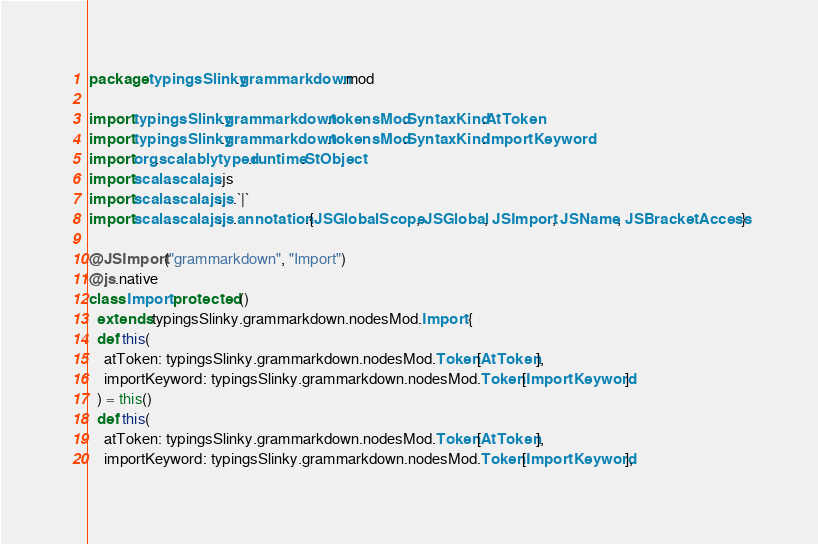<code> <loc_0><loc_0><loc_500><loc_500><_Scala_>package typingsSlinky.grammarkdown.mod

import typingsSlinky.grammarkdown.tokensMod.SyntaxKind.AtToken
import typingsSlinky.grammarkdown.tokensMod.SyntaxKind.ImportKeyword
import org.scalablytyped.runtime.StObject
import scala.scalajs.js
import scala.scalajs.js.`|`
import scala.scalajs.js.annotation.{JSGlobalScope, JSGlobal, JSImport, JSName, JSBracketAccess}

@JSImport("grammarkdown", "Import")
@js.native
class Import protected ()
  extends typingsSlinky.grammarkdown.nodesMod.Import {
  def this(
    atToken: typingsSlinky.grammarkdown.nodesMod.Token[AtToken],
    importKeyword: typingsSlinky.grammarkdown.nodesMod.Token[ImportKeyword]
  ) = this()
  def this(
    atToken: typingsSlinky.grammarkdown.nodesMod.Token[AtToken],
    importKeyword: typingsSlinky.grammarkdown.nodesMod.Token[ImportKeyword],</code> 